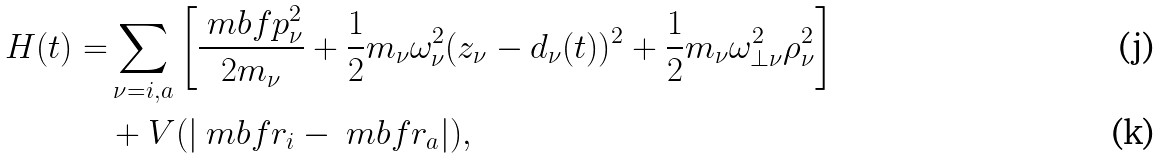Convert formula to latex. <formula><loc_0><loc_0><loc_500><loc_500>H ( t ) = & \sum _ { \nu = i , a } \left [ \frac { \ m b f { p } _ { \nu } ^ { 2 } } { 2 m _ { \nu } } + \frac { 1 } { 2 } m _ { \nu } \omega _ { \nu } ^ { 2 } ( z _ { \nu } - d _ { \nu } ( t ) ) ^ { 2 } + \frac { 1 } { 2 } m _ { \nu } \omega _ { \perp \nu } ^ { 2 } \rho _ { \nu } ^ { 2 } \right ] \\ & + V ( | \ m b f { r } _ { i } - \ m b f { r } _ { a } | ) ,</formula> 